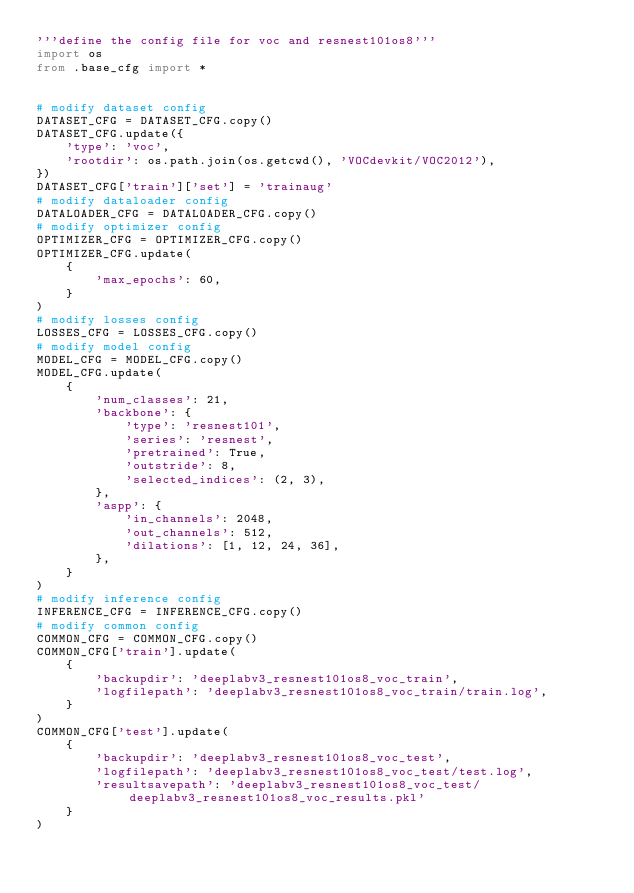Convert code to text. <code><loc_0><loc_0><loc_500><loc_500><_Python_>'''define the config file for voc and resnest101os8'''
import os
from .base_cfg import *


# modify dataset config
DATASET_CFG = DATASET_CFG.copy()
DATASET_CFG.update({
    'type': 'voc',
    'rootdir': os.path.join(os.getcwd(), 'VOCdevkit/VOC2012'),
})
DATASET_CFG['train']['set'] = 'trainaug'
# modify dataloader config
DATALOADER_CFG = DATALOADER_CFG.copy()
# modify optimizer config
OPTIMIZER_CFG = OPTIMIZER_CFG.copy()
OPTIMIZER_CFG.update(
    {
        'max_epochs': 60,
    }
)
# modify losses config
LOSSES_CFG = LOSSES_CFG.copy()
# modify model config
MODEL_CFG = MODEL_CFG.copy()
MODEL_CFG.update(
    {
        'num_classes': 21,
        'backbone': {
            'type': 'resnest101',
            'series': 'resnest',
            'pretrained': True,
            'outstride': 8,
            'selected_indices': (2, 3),
        },
        'aspp': {
            'in_channels': 2048,
            'out_channels': 512,
            'dilations': [1, 12, 24, 36],
        },
    }
)
# modify inference config
INFERENCE_CFG = INFERENCE_CFG.copy()
# modify common config
COMMON_CFG = COMMON_CFG.copy()
COMMON_CFG['train'].update(
    {
        'backupdir': 'deeplabv3_resnest101os8_voc_train',
        'logfilepath': 'deeplabv3_resnest101os8_voc_train/train.log',
    }
)
COMMON_CFG['test'].update(
    {
        'backupdir': 'deeplabv3_resnest101os8_voc_test',
        'logfilepath': 'deeplabv3_resnest101os8_voc_test/test.log',
        'resultsavepath': 'deeplabv3_resnest101os8_voc_test/deeplabv3_resnest101os8_voc_results.pkl'
    }
)</code> 